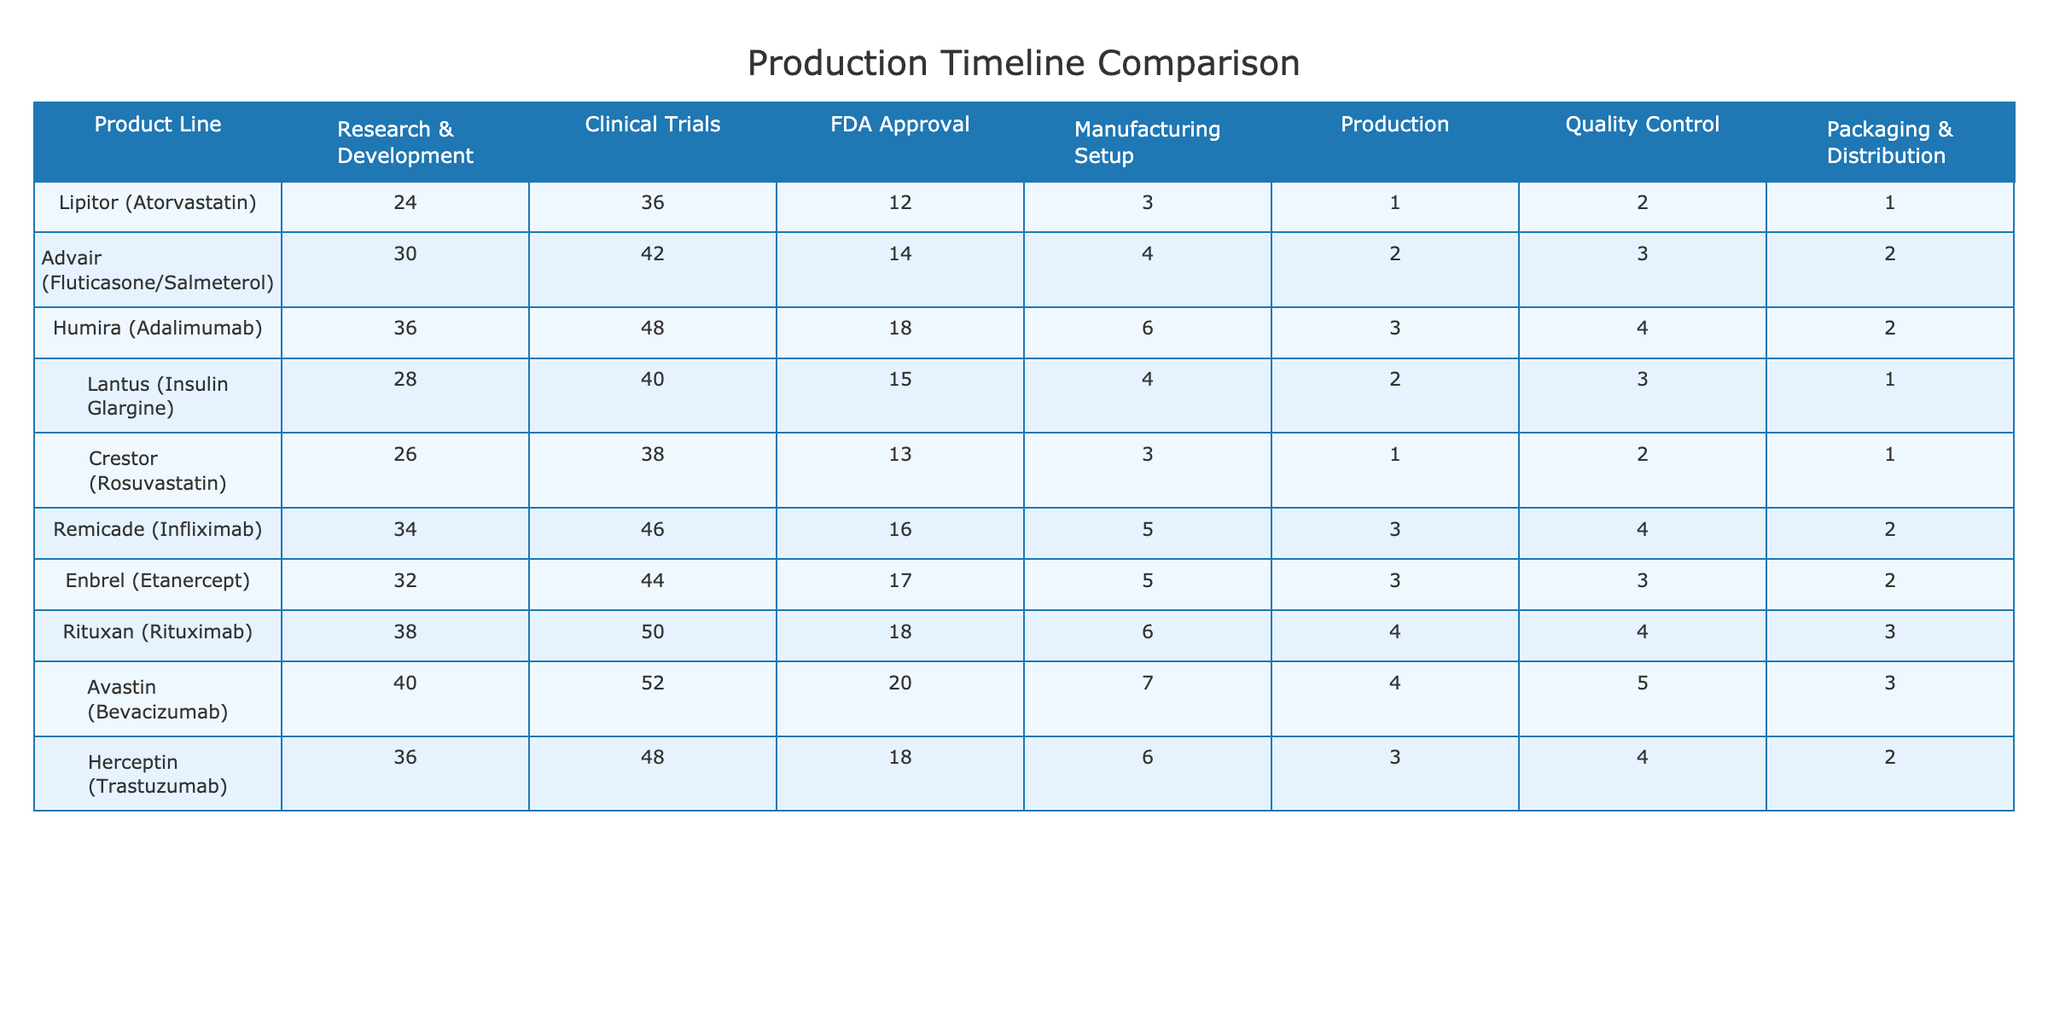What is the total time for manufacturing setup for Lipitor? In the table, the manufacturing setup time for Lipitor (Atorvastatin) is listed as 3 months. Therefore, the total time for manufacturing setup is simply 3.
Answer: 3 Which product line has the shortest production time? Looking at the Production column, Lipitor (Atorvastatin) has the shortest production time of 1 month compared to the others.
Answer: Lipitor (Atorvastatin) What is the average time for Quality Control across all product lines? To calculate the average, we sum the Quality Control times: (2 + 3 + 4 + 3 + 2 + 4 + 3 + 4 + 5 + 2) = 33. There are 10 product lines, so the average is 33/10 = 3.3.
Answer: 3.3 Did any product line have a total timeline (sum of all processes) that exceeds 100 months? We calculate the total timeline for each product by summing all columns for each product line. The maximum value is Humira with a total of 117 months, exceeding 100 months.
Answer: Yes What is the difference in the FDA Approval time between the product lines with the longest and shortest times? The longest FDA Approval time is for Avastin, which is 20 months. The shortest is for Lipitor at 12 months. The difference is 20 - 12 = 8 months.
Answer: 8 Which two product lines have the highest total production timeline? Summing the timeline for each product line, the two highest totals are Avastin (20 + 52 + 7 + 4 + 5 + 3 = 91) and Rituxan (18 + 50 + 6 + 4 + 4 + 3 = 85).
Answer: Avastin and Rituxan Is the sum of the Research & Development times for the top three product lines greater than 100 months? The top three product lines by R&D time are Humira (36), Avastin (40), and Rituxan (38). The sum is 36 + 40 + 38 = 114 months, which is greater than 100.
Answer: Yes What proportion of the total time for Clinical Trials is taken by Enbrel? The Clinical Trials total is the sum of all values in that category: (36 + 42 + 48 + 40 + 38 + 46 + 44 + 50 + 52 + 48) = 424. Enbrel's time is 44 months, so the proportion is 44/424 = 0.1038 or approximately 10.38%.
Answer: 10.38% Which product line requires the highest number of months in Clinical Trials and what is that number? From the Clinical Trials column, Humira has the highest time at 48 months.
Answer: 48 How many product lines have a Packaging & Distribution time of less than 2 months? Reviewing the Packaging & Distribution column, only Lipitor and Lantus have a time of less than 2 months, making it a total of 2 product lines.
Answer: 2 